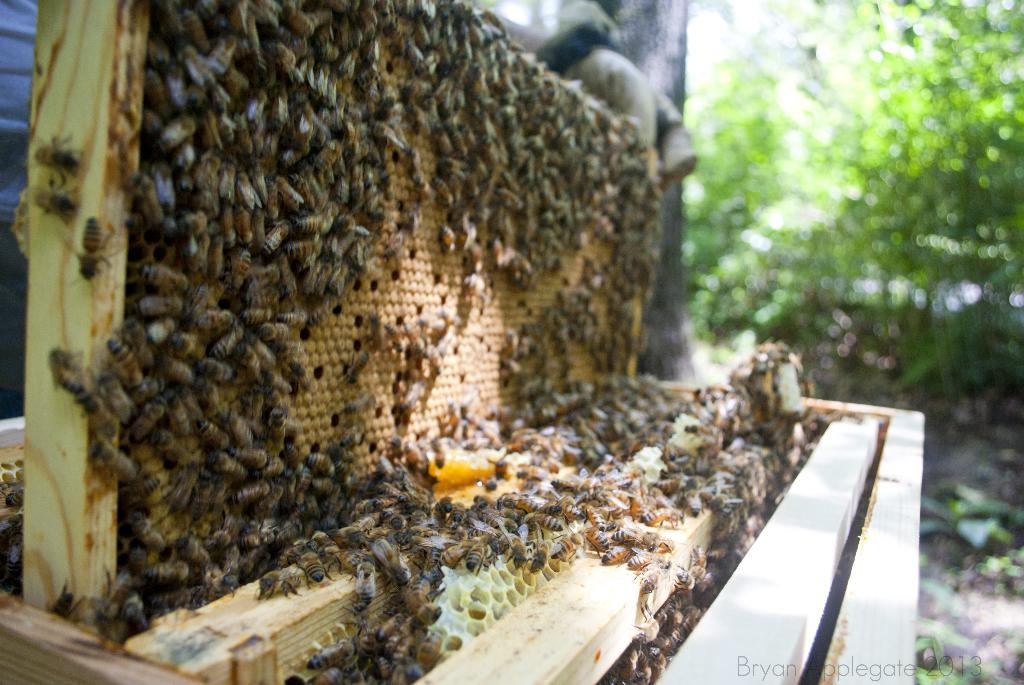What type of insects can be seen in the image? There are honey bees in the image. Where is the beehive located in the image? The beehive is on the left side of the image. What can be seen in the background of the image? There is a tree in the background of the image. What material is present in the image? Wood is present in the image. What type of quiver can be seen on the sidewalk in the image? There is no sidewalk, volcano, or quiver present in the image. 